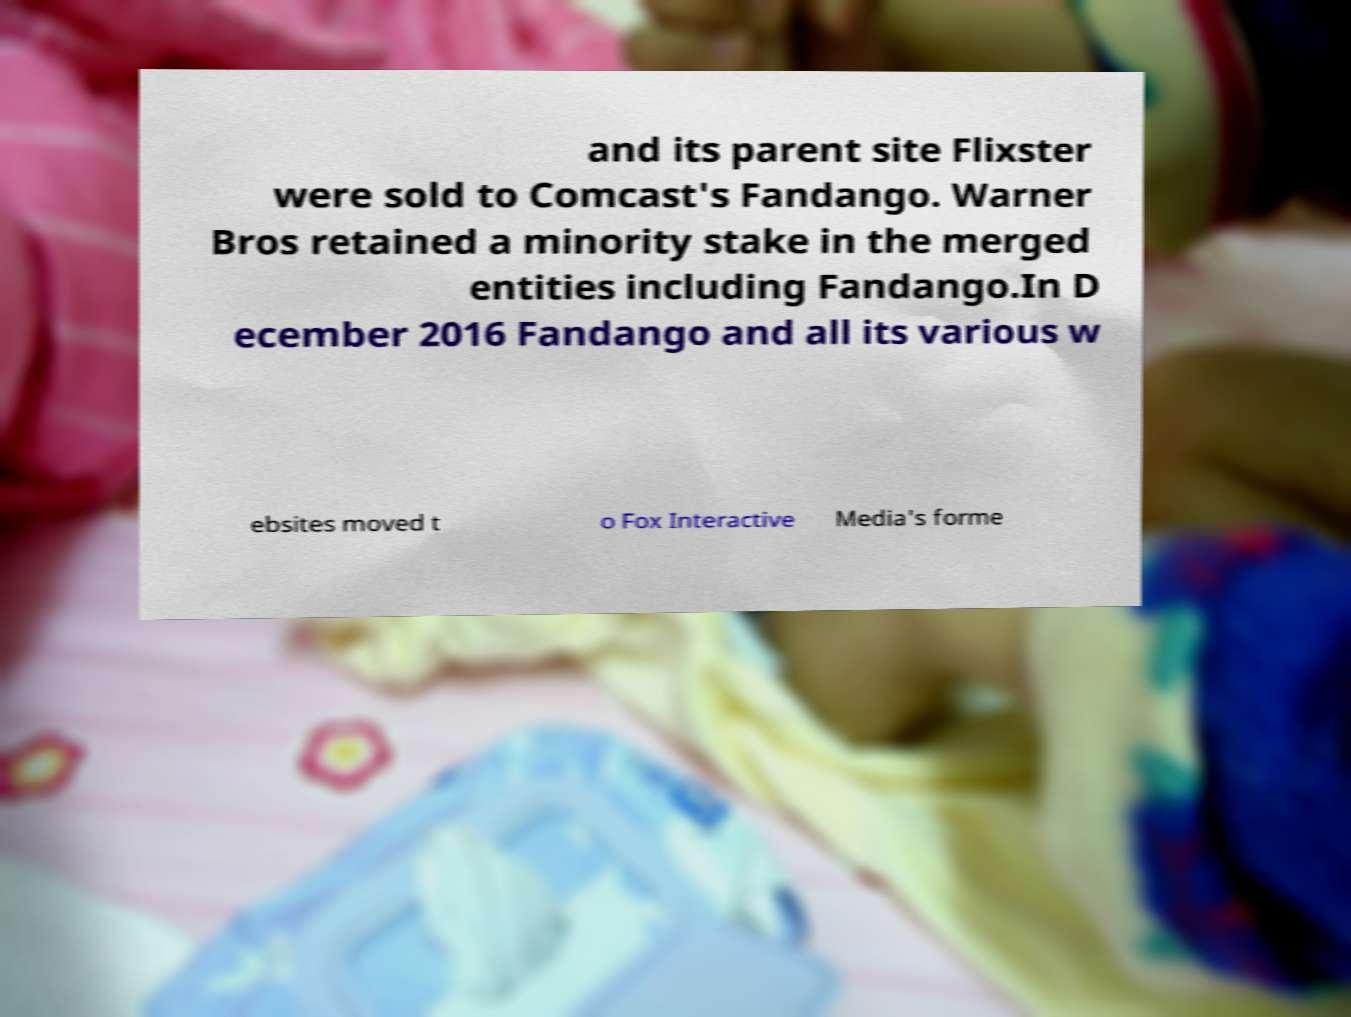I need the written content from this picture converted into text. Can you do that? and its parent site Flixster were sold to Comcast's Fandango. Warner Bros retained a minority stake in the merged entities including Fandango.In D ecember 2016 Fandango and all its various w ebsites moved t o Fox Interactive Media's forme 